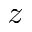<formula> <loc_0><loc_0><loc_500><loc_500>\ m a t h s c r { z }</formula> 